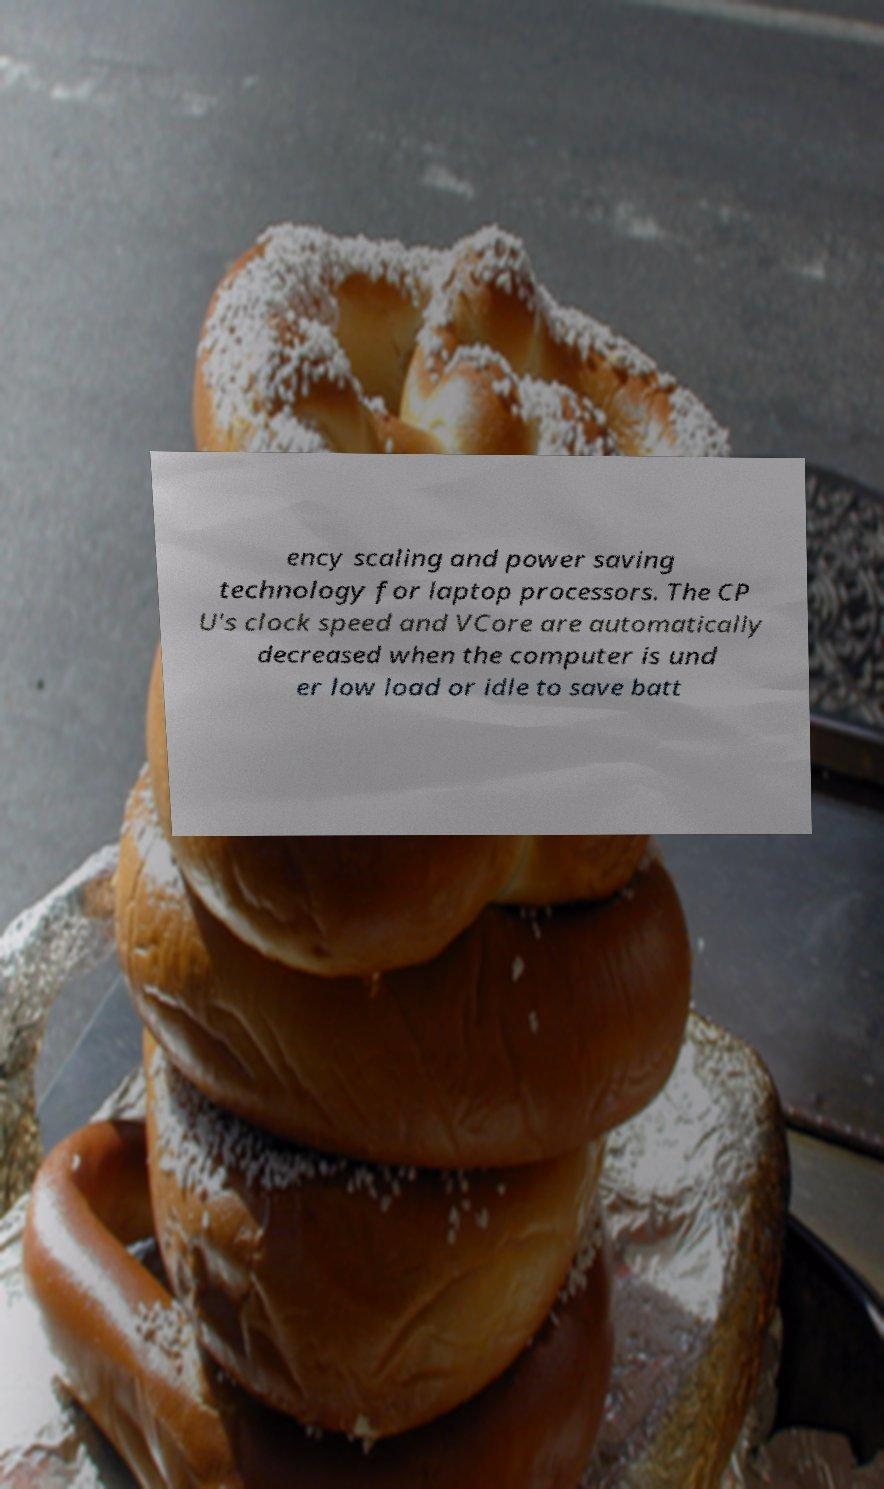There's text embedded in this image that I need extracted. Can you transcribe it verbatim? ency scaling and power saving technology for laptop processors. The CP U's clock speed and VCore are automatically decreased when the computer is und er low load or idle to save batt 